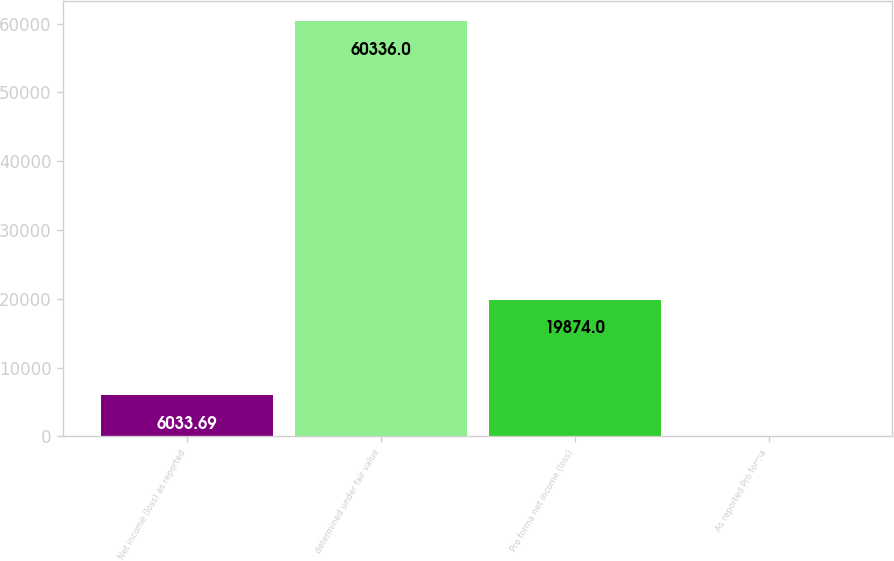Convert chart. <chart><loc_0><loc_0><loc_500><loc_500><bar_chart><fcel>Net income (loss) as reported<fcel>determined under fair value<fcel>Pro forma net income (loss)<fcel>As reported Pro forma<nl><fcel>6033.69<fcel>60336<fcel>19874<fcel>0.1<nl></chart> 